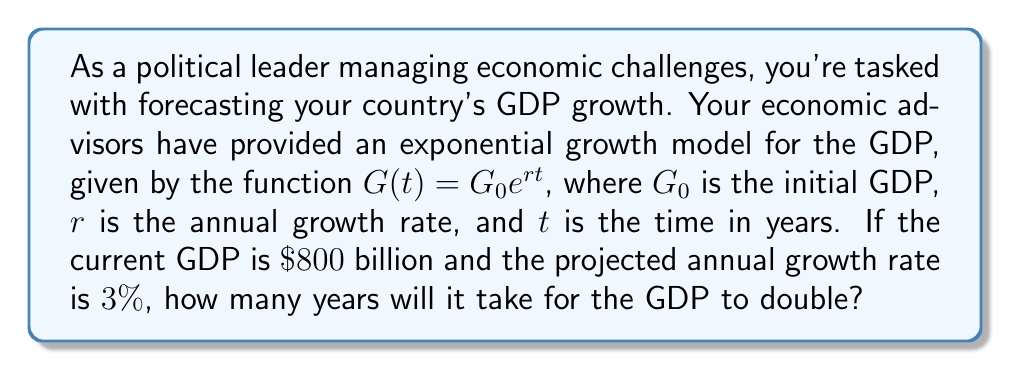Give your solution to this math problem. To solve this problem, we'll use the exponential growth formula and the concept of doubling time:

1) The exponential growth formula is given by:
   $$G(t) = G_0 e^{rt}$$

2) We want to find $t$ when $G(t)$ is twice the initial value:
   $$2G_0 = G_0 e^{rt}$$

3) Divide both sides by $G_0$:
   $$2 = e^{rt}$$

4) Take the natural logarithm of both sides:
   $$\ln(2) = rt$$

5) Solve for $t$:
   $$t = \frac{\ln(2)}{r}$$

6) We're given that $r = 3\% = 0.03$. Substitute this:
   $$t = \frac{\ln(2)}{0.03}$$

7) Calculate:
   $$t \approx 23.10$$

8) Since we're dealing with years, we round up to the nearest whole year.
Answer: It will take 24 years for the GDP to double. 